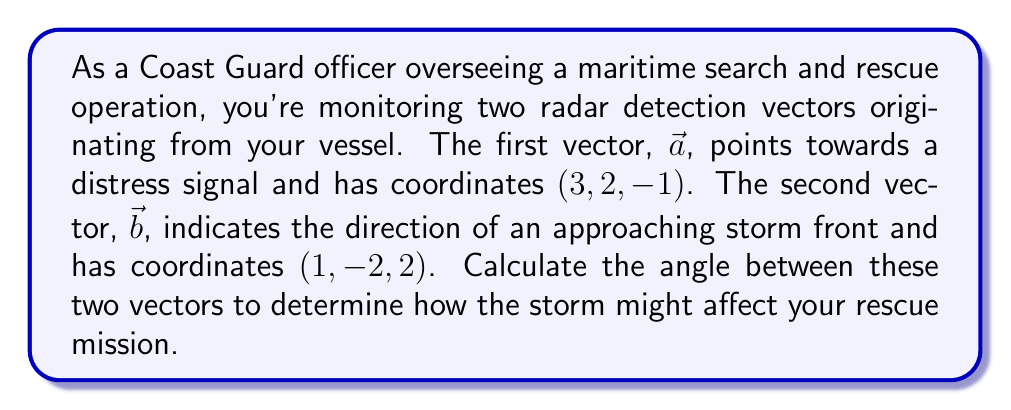Give your solution to this math problem. To find the angle between two vectors in 3D space, we can use the dot product formula:

$$\cos \theta = \frac{\vec{a} \cdot \vec{b}}{|\vec{a}| |\vec{b}|}$$

Where $\theta$ is the angle between the vectors, $\vec{a} \cdot \vec{b}$ is the dot product, and $|\vec{a}|$ and $|\vec{b}|$ are the magnitudes of the vectors.

Step 1: Calculate the dot product $\vec{a} \cdot \vec{b}$
$$\vec{a} \cdot \vec{b} = (3)(1) + (2)(-2) + (-1)(2) = 3 - 4 - 2 = -3$$

Step 2: Calculate the magnitudes of $\vec{a}$ and $\vec{b}$
$$|\vec{a}| = \sqrt{3^2 + 2^2 + (-1)^2} = \sqrt{9 + 4 + 1} = \sqrt{14}$$
$$|\vec{b}| = \sqrt{1^2 + (-2)^2 + 2^2} = \sqrt{1 + 4 + 4} = 3$$

Step 3: Substitute into the formula
$$\cos \theta = \frac{-3}{(\sqrt{14})(3)}$$

Step 4: Solve for $\theta$
$$\theta = \arccos\left(\frac{-3}{3\sqrt{14}}\right)$$

Step 5: Convert to degrees
$$\theta = \arccos\left(\frac{-1}{\sqrt{14}}\right) \cdot \frac{180°}{\pi} \approx 105.21°$$
Answer: The angle between the two radar detection vectors is approximately $105.21°$. 